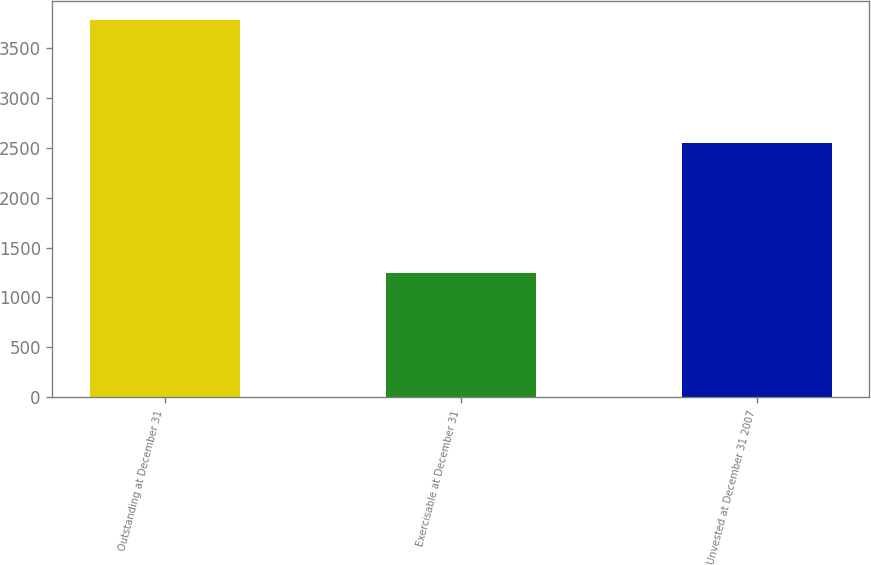<chart> <loc_0><loc_0><loc_500><loc_500><bar_chart><fcel>Outstanding at December 31<fcel>Exercisable at December 31<fcel>Unvested at December 31 2007<nl><fcel>3787<fcel>1241<fcel>2546<nl></chart> 